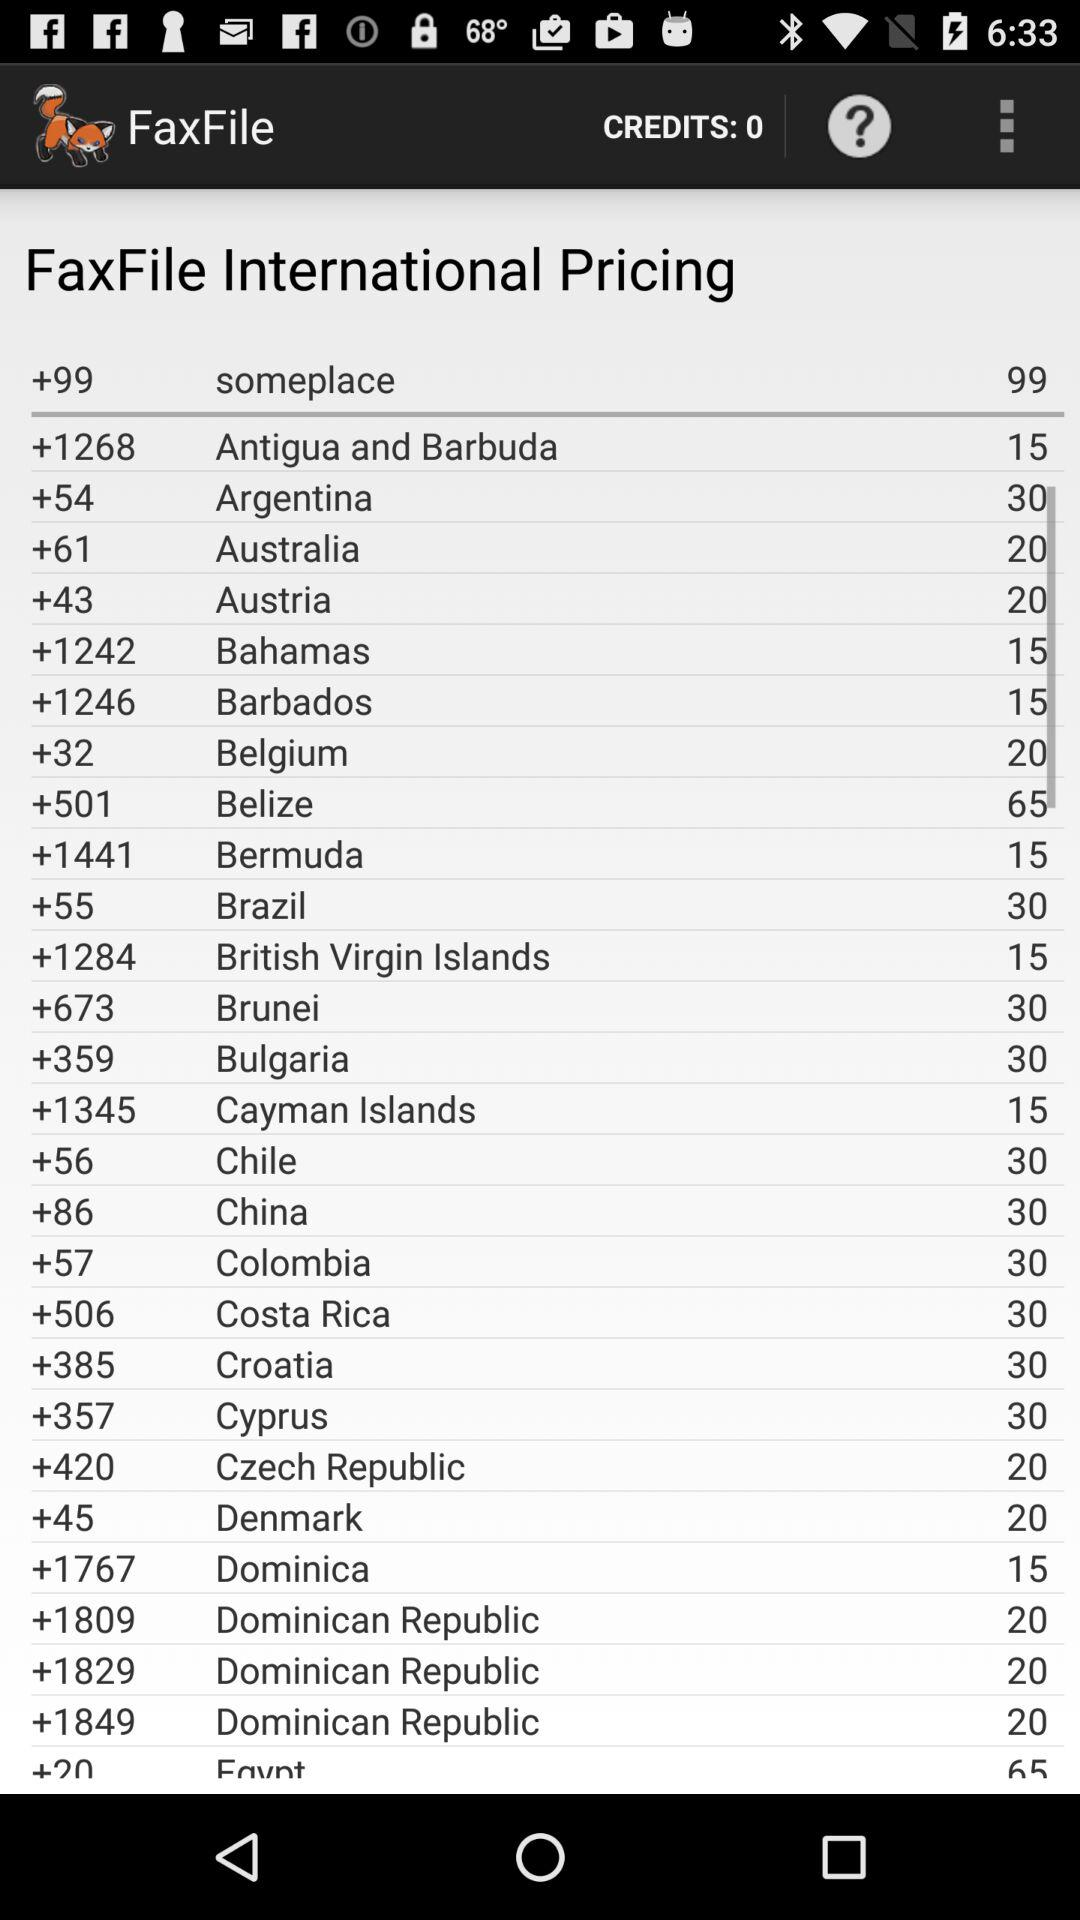What's the dial code for Australia? The dial code for Australia is +61. 